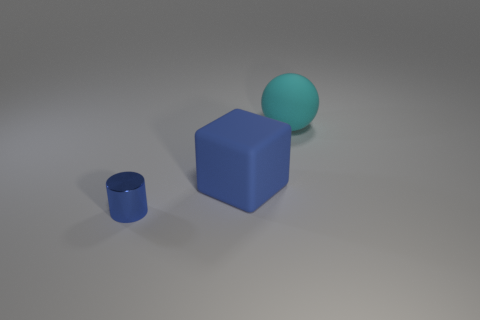Add 2 big balls. How many objects exist? 5 Add 2 large brown matte cylinders. How many large brown matte cylinders exist? 2 Subtract 1 blue cylinders. How many objects are left? 2 Subtract all cylinders. How many objects are left? 2 Subtract 1 cylinders. How many cylinders are left? 0 Subtract all purple cubes. Subtract all blue balls. How many cubes are left? 1 Subtract all big gray spheres. Subtract all metallic cylinders. How many objects are left? 2 Add 2 large rubber things. How many large rubber things are left? 4 